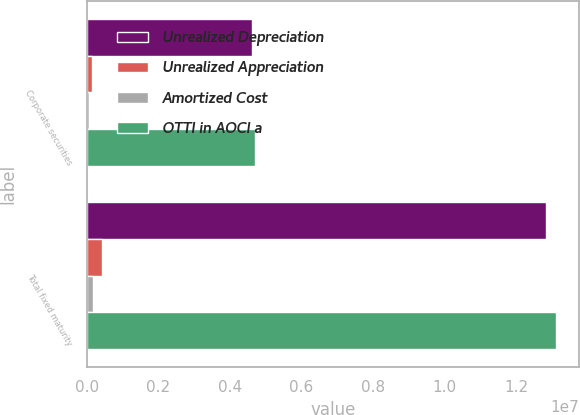Convert chart. <chart><loc_0><loc_0><loc_500><loc_500><stacked_bar_chart><ecel><fcel>Corporate securities<fcel>Total fixed maturity<nl><fcel>Unrealized Depreciation<fcel>4.626e+06<fcel>1.28312e+07<nl><fcel>Unrealized Appreciation<fcel>143889<fcel>426973<nl><fcel>Amortized Cost<fcel>62906<fcel>157065<nl><fcel>OTTI in AOCI a<fcel>4.70698e+06<fcel>1.31011e+07<nl></chart> 